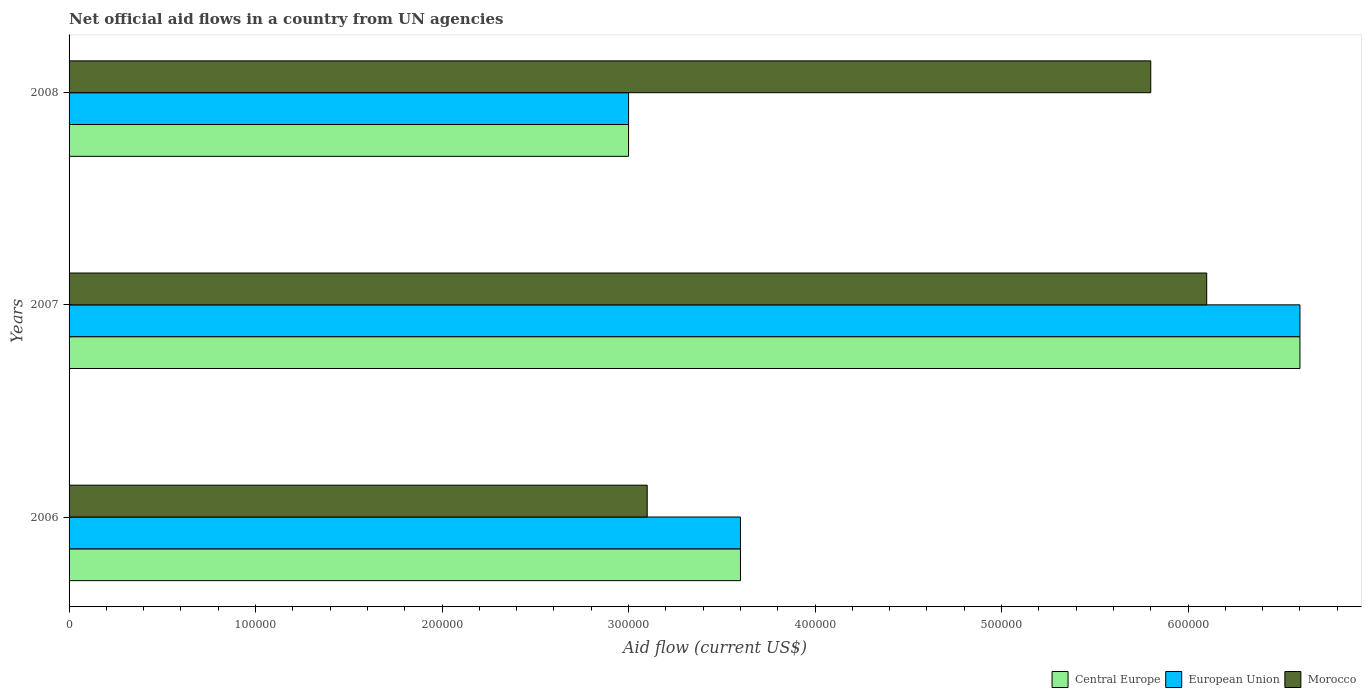How many groups of bars are there?
Provide a short and direct response. 3. Are the number of bars on each tick of the Y-axis equal?
Provide a short and direct response. Yes. How many bars are there on the 1st tick from the top?
Your answer should be very brief. 3. In how many cases, is the number of bars for a given year not equal to the number of legend labels?
Give a very brief answer. 0. What is the net official aid flow in Morocco in 2006?
Give a very brief answer. 3.10e+05. Across all years, what is the maximum net official aid flow in Morocco?
Your answer should be compact. 6.10e+05. In which year was the net official aid flow in Morocco maximum?
Your answer should be compact. 2007. What is the total net official aid flow in Central Europe in the graph?
Provide a short and direct response. 1.32e+06. What is the difference between the net official aid flow in Morocco in 2006 and that in 2007?
Make the answer very short. -3.00e+05. What is the ratio of the net official aid flow in Morocco in 2007 to that in 2008?
Make the answer very short. 1.05. What is the difference between the highest and the lowest net official aid flow in Morocco?
Keep it short and to the point. 3.00e+05. Is the sum of the net official aid flow in European Union in 2006 and 2008 greater than the maximum net official aid flow in Morocco across all years?
Provide a short and direct response. Yes. What does the 1st bar from the top in 2006 represents?
Offer a very short reply. Morocco. What does the 3rd bar from the bottom in 2007 represents?
Give a very brief answer. Morocco. Is it the case that in every year, the sum of the net official aid flow in Morocco and net official aid flow in European Union is greater than the net official aid flow in Central Europe?
Keep it short and to the point. Yes. Are all the bars in the graph horizontal?
Make the answer very short. Yes. How many years are there in the graph?
Your response must be concise. 3. What is the difference between two consecutive major ticks on the X-axis?
Offer a very short reply. 1.00e+05. Are the values on the major ticks of X-axis written in scientific E-notation?
Offer a terse response. No. Does the graph contain any zero values?
Your answer should be very brief. No. Where does the legend appear in the graph?
Provide a short and direct response. Bottom right. What is the title of the graph?
Make the answer very short. Net official aid flows in a country from UN agencies. Does "Israel" appear as one of the legend labels in the graph?
Provide a short and direct response. No. What is the label or title of the X-axis?
Give a very brief answer. Aid flow (current US$). What is the Aid flow (current US$) of Central Europe in 2006?
Your response must be concise. 3.60e+05. What is the Aid flow (current US$) in Morocco in 2006?
Your answer should be very brief. 3.10e+05. What is the Aid flow (current US$) of Morocco in 2007?
Provide a succinct answer. 6.10e+05. What is the Aid flow (current US$) in Central Europe in 2008?
Make the answer very short. 3.00e+05. What is the Aid flow (current US$) of Morocco in 2008?
Your answer should be compact. 5.80e+05. Across all years, what is the maximum Aid flow (current US$) of Central Europe?
Make the answer very short. 6.60e+05. Across all years, what is the maximum Aid flow (current US$) of European Union?
Offer a very short reply. 6.60e+05. Across all years, what is the maximum Aid flow (current US$) in Morocco?
Provide a succinct answer. 6.10e+05. Across all years, what is the minimum Aid flow (current US$) of Central Europe?
Your answer should be compact. 3.00e+05. Across all years, what is the minimum Aid flow (current US$) in Morocco?
Offer a very short reply. 3.10e+05. What is the total Aid flow (current US$) of Central Europe in the graph?
Offer a terse response. 1.32e+06. What is the total Aid flow (current US$) in European Union in the graph?
Your response must be concise. 1.32e+06. What is the total Aid flow (current US$) in Morocco in the graph?
Give a very brief answer. 1.50e+06. What is the difference between the Aid flow (current US$) in Morocco in 2006 and that in 2007?
Provide a short and direct response. -3.00e+05. What is the difference between the Aid flow (current US$) of Central Europe in 2006 and that in 2008?
Offer a very short reply. 6.00e+04. What is the difference between the Aid flow (current US$) of European Union in 2006 and that in 2008?
Your answer should be very brief. 6.00e+04. What is the difference between the Aid flow (current US$) of Morocco in 2006 and that in 2008?
Keep it short and to the point. -2.70e+05. What is the difference between the Aid flow (current US$) of European Union in 2007 and that in 2008?
Ensure brevity in your answer.  3.60e+05. What is the difference between the Aid flow (current US$) of Morocco in 2007 and that in 2008?
Provide a short and direct response. 3.00e+04. What is the difference between the Aid flow (current US$) of Central Europe in 2006 and the Aid flow (current US$) of European Union in 2008?
Your answer should be compact. 6.00e+04. What is the difference between the Aid flow (current US$) in Central Europe in 2006 and the Aid flow (current US$) in Morocco in 2008?
Provide a short and direct response. -2.20e+05. What is the difference between the Aid flow (current US$) of Central Europe in 2007 and the Aid flow (current US$) of European Union in 2008?
Your answer should be compact. 3.60e+05. What is the difference between the Aid flow (current US$) of Central Europe in 2007 and the Aid flow (current US$) of Morocco in 2008?
Make the answer very short. 8.00e+04. What is the difference between the Aid flow (current US$) of European Union in 2007 and the Aid flow (current US$) of Morocco in 2008?
Offer a terse response. 8.00e+04. What is the average Aid flow (current US$) of Central Europe per year?
Your response must be concise. 4.40e+05. In the year 2006, what is the difference between the Aid flow (current US$) in Central Europe and Aid flow (current US$) in European Union?
Give a very brief answer. 0. In the year 2006, what is the difference between the Aid flow (current US$) in Central Europe and Aid flow (current US$) in Morocco?
Offer a terse response. 5.00e+04. In the year 2006, what is the difference between the Aid flow (current US$) in European Union and Aid flow (current US$) in Morocco?
Your answer should be compact. 5.00e+04. In the year 2007, what is the difference between the Aid flow (current US$) in Central Europe and Aid flow (current US$) in Morocco?
Keep it short and to the point. 5.00e+04. In the year 2007, what is the difference between the Aid flow (current US$) of European Union and Aid flow (current US$) of Morocco?
Offer a very short reply. 5.00e+04. In the year 2008, what is the difference between the Aid flow (current US$) in Central Europe and Aid flow (current US$) in European Union?
Provide a succinct answer. 0. In the year 2008, what is the difference between the Aid flow (current US$) of Central Europe and Aid flow (current US$) of Morocco?
Make the answer very short. -2.80e+05. In the year 2008, what is the difference between the Aid flow (current US$) of European Union and Aid flow (current US$) of Morocco?
Make the answer very short. -2.80e+05. What is the ratio of the Aid flow (current US$) of Central Europe in 2006 to that in 2007?
Keep it short and to the point. 0.55. What is the ratio of the Aid flow (current US$) of European Union in 2006 to that in 2007?
Your answer should be very brief. 0.55. What is the ratio of the Aid flow (current US$) of Morocco in 2006 to that in 2007?
Give a very brief answer. 0.51. What is the ratio of the Aid flow (current US$) of Central Europe in 2006 to that in 2008?
Offer a very short reply. 1.2. What is the ratio of the Aid flow (current US$) in Morocco in 2006 to that in 2008?
Offer a very short reply. 0.53. What is the ratio of the Aid flow (current US$) in Central Europe in 2007 to that in 2008?
Offer a terse response. 2.2. What is the ratio of the Aid flow (current US$) of Morocco in 2007 to that in 2008?
Keep it short and to the point. 1.05. What is the difference between the highest and the second highest Aid flow (current US$) of European Union?
Your answer should be very brief. 3.00e+05. What is the difference between the highest and the lowest Aid flow (current US$) in Central Europe?
Provide a short and direct response. 3.60e+05. 